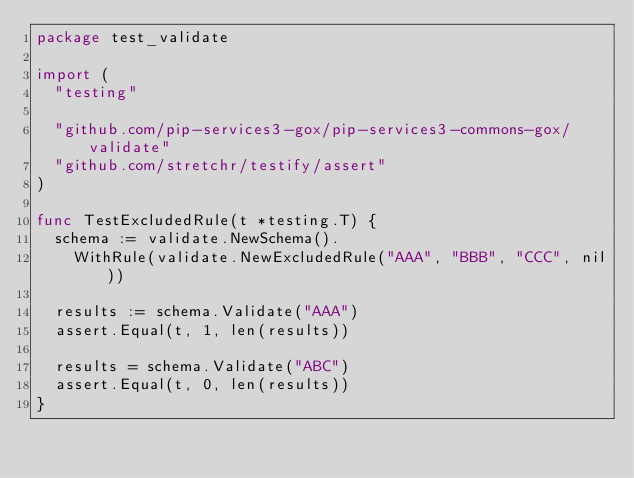Convert code to text. <code><loc_0><loc_0><loc_500><loc_500><_Go_>package test_validate

import (
	"testing"

	"github.com/pip-services3-gox/pip-services3-commons-gox/validate"
	"github.com/stretchr/testify/assert"
)

func TestExcludedRule(t *testing.T) {
	schema := validate.NewSchema().
		WithRule(validate.NewExcludedRule("AAA", "BBB", "CCC", nil))

	results := schema.Validate("AAA")
	assert.Equal(t, 1, len(results))

	results = schema.Validate("ABC")
	assert.Equal(t, 0, len(results))
}
</code> 